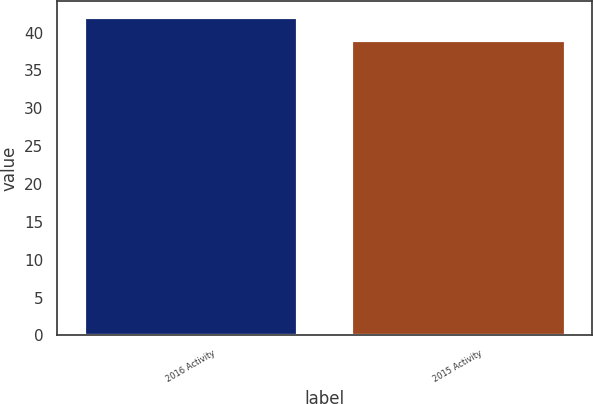<chart> <loc_0><loc_0><loc_500><loc_500><bar_chart><fcel>2016 Activity<fcel>2015 Activity<nl><fcel>42<fcel>39<nl></chart> 